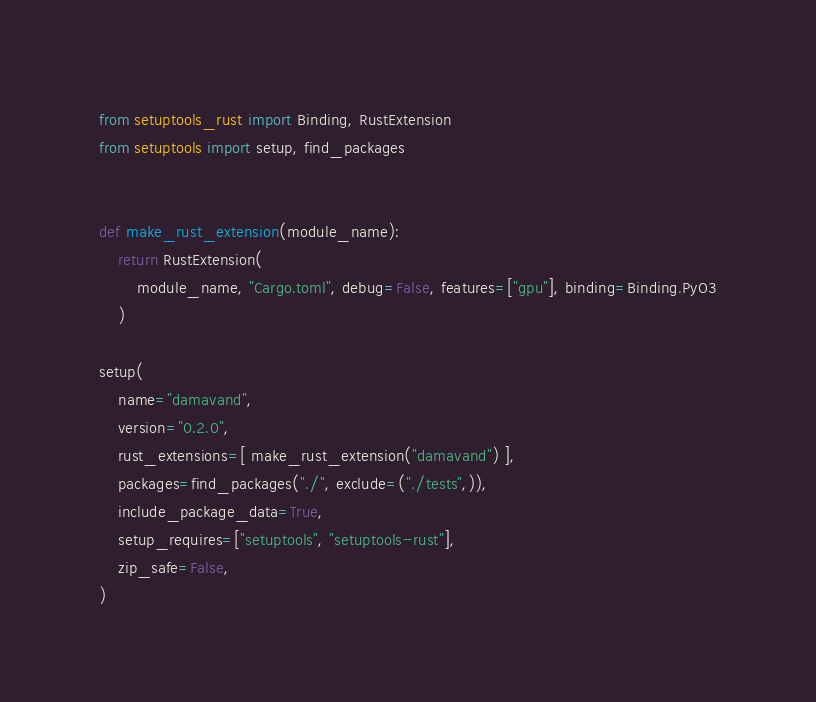<code> <loc_0><loc_0><loc_500><loc_500><_Python_>from setuptools_rust import Binding, RustExtension
from setuptools import setup, find_packages


def make_rust_extension(module_name):
    return RustExtension(
        module_name, "Cargo.toml", debug=False, features=["gpu"], binding=Binding.PyO3
    )

setup(
    name="damavand",
    version="0.2.0",
    rust_extensions=[ make_rust_extension("damavand") ],
    packages=find_packages("./", exclude=("./tests",)),
    include_package_data=True,
    setup_requires=["setuptools", "setuptools-rust"],
    zip_safe=False,
)
</code> 